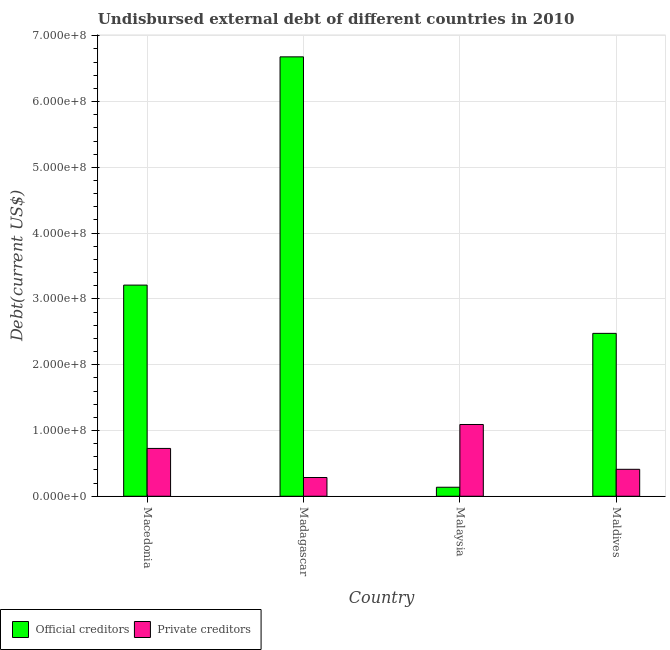Are the number of bars per tick equal to the number of legend labels?
Provide a short and direct response. Yes. Are the number of bars on each tick of the X-axis equal?
Ensure brevity in your answer.  Yes. What is the label of the 2nd group of bars from the left?
Your answer should be very brief. Madagascar. What is the undisbursed external debt of private creditors in Madagascar?
Offer a very short reply. 2.85e+07. Across all countries, what is the maximum undisbursed external debt of private creditors?
Ensure brevity in your answer.  1.09e+08. Across all countries, what is the minimum undisbursed external debt of official creditors?
Provide a short and direct response. 1.37e+07. In which country was the undisbursed external debt of private creditors maximum?
Give a very brief answer. Malaysia. In which country was the undisbursed external debt of official creditors minimum?
Your response must be concise. Malaysia. What is the total undisbursed external debt of official creditors in the graph?
Provide a short and direct response. 1.25e+09. What is the difference between the undisbursed external debt of official creditors in Malaysia and that in Maldives?
Your response must be concise. -2.34e+08. What is the difference between the undisbursed external debt of official creditors in Maldives and the undisbursed external debt of private creditors in Madagascar?
Provide a succinct answer. 2.19e+08. What is the average undisbursed external debt of private creditors per country?
Your response must be concise. 6.28e+07. What is the difference between the undisbursed external debt of private creditors and undisbursed external debt of official creditors in Macedonia?
Offer a very short reply. -2.48e+08. What is the ratio of the undisbursed external debt of official creditors in Madagascar to that in Malaysia?
Keep it short and to the point. 48.81. Is the undisbursed external debt of official creditors in Malaysia less than that in Maldives?
Provide a succinct answer. Yes. What is the difference between the highest and the second highest undisbursed external debt of official creditors?
Your response must be concise. 3.47e+08. What is the difference between the highest and the lowest undisbursed external debt of private creditors?
Give a very brief answer. 8.06e+07. In how many countries, is the undisbursed external debt of private creditors greater than the average undisbursed external debt of private creditors taken over all countries?
Make the answer very short. 2. Is the sum of the undisbursed external debt of official creditors in Madagascar and Maldives greater than the maximum undisbursed external debt of private creditors across all countries?
Make the answer very short. Yes. What does the 1st bar from the left in Malaysia represents?
Your response must be concise. Official creditors. What does the 2nd bar from the right in Maldives represents?
Give a very brief answer. Official creditors. How many bars are there?
Ensure brevity in your answer.  8. Are all the bars in the graph horizontal?
Ensure brevity in your answer.  No. How many countries are there in the graph?
Offer a terse response. 4. What is the difference between two consecutive major ticks on the Y-axis?
Offer a very short reply. 1.00e+08. Does the graph contain grids?
Make the answer very short. Yes. What is the title of the graph?
Your response must be concise. Undisbursed external debt of different countries in 2010. What is the label or title of the X-axis?
Your response must be concise. Country. What is the label or title of the Y-axis?
Provide a succinct answer. Debt(current US$). What is the Debt(current US$) of Official creditors in Macedonia?
Offer a very short reply. 3.21e+08. What is the Debt(current US$) of Private creditors in Macedonia?
Ensure brevity in your answer.  7.27e+07. What is the Debt(current US$) of Official creditors in Madagascar?
Offer a terse response. 6.68e+08. What is the Debt(current US$) of Private creditors in Madagascar?
Your answer should be compact. 2.85e+07. What is the Debt(current US$) of Official creditors in Malaysia?
Your answer should be very brief. 1.37e+07. What is the Debt(current US$) in Private creditors in Malaysia?
Your response must be concise. 1.09e+08. What is the Debt(current US$) of Official creditors in Maldives?
Your answer should be very brief. 2.48e+08. What is the Debt(current US$) in Private creditors in Maldives?
Your answer should be compact. 4.10e+07. Across all countries, what is the maximum Debt(current US$) in Official creditors?
Offer a very short reply. 6.68e+08. Across all countries, what is the maximum Debt(current US$) of Private creditors?
Give a very brief answer. 1.09e+08. Across all countries, what is the minimum Debt(current US$) in Official creditors?
Give a very brief answer. 1.37e+07. Across all countries, what is the minimum Debt(current US$) of Private creditors?
Offer a very short reply. 2.85e+07. What is the total Debt(current US$) in Official creditors in the graph?
Ensure brevity in your answer.  1.25e+09. What is the total Debt(current US$) of Private creditors in the graph?
Provide a short and direct response. 2.51e+08. What is the difference between the Debt(current US$) in Official creditors in Macedonia and that in Madagascar?
Provide a succinct answer. -3.47e+08. What is the difference between the Debt(current US$) of Private creditors in Macedonia and that in Madagascar?
Provide a short and direct response. 4.42e+07. What is the difference between the Debt(current US$) in Official creditors in Macedonia and that in Malaysia?
Keep it short and to the point. 3.07e+08. What is the difference between the Debt(current US$) in Private creditors in Macedonia and that in Malaysia?
Keep it short and to the point. -3.64e+07. What is the difference between the Debt(current US$) of Official creditors in Macedonia and that in Maldives?
Keep it short and to the point. 7.34e+07. What is the difference between the Debt(current US$) of Private creditors in Macedonia and that in Maldives?
Ensure brevity in your answer.  3.17e+07. What is the difference between the Debt(current US$) of Official creditors in Madagascar and that in Malaysia?
Ensure brevity in your answer.  6.54e+08. What is the difference between the Debt(current US$) of Private creditors in Madagascar and that in Malaysia?
Make the answer very short. -8.06e+07. What is the difference between the Debt(current US$) of Official creditors in Madagascar and that in Maldives?
Your response must be concise. 4.20e+08. What is the difference between the Debt(current US$) in Private creditors in Madagascar and that in Maldives?
Your answer should be compact. -1.25e+07. What is the difference between the Debt(current US$) in Official creditors in Malaysia and that in Maldives?
Your answer should be very brief. -2.34e+08. What is the difference between the Debt(current US$) in Private creditors in Malaysia and that in Maldives?
Your answer should be very brief. 6.81e+07. What is the difference between the Debt(current US$) of Official creditors in Macedonia and the Debt(current US$) of Private creditors in Madagascar?
Keep it short and to the point. 2.92e+08. What is the difference between the Debt(current US$) of Official creditors in Macedonia and the Debt(current US$) of Private creditors in Malaysia?
Offer a very short reply. 2.12e+08. What is the difference between the Debt(current US$) of Official creditors in Macedonia and the Debt(current US$) of Private creditors in Maldives?
Provide a short and direct response. 2.80e+08. What is the difference between the Debt(current US$) of Official creditors in Madagascar and the Debt(current US$) of Private creditors in Malaysia?
Your answer should be compact. 5.59e+08. What is the difference between the Debt(current US$) of Official creditors in Madagascar and the Debt(current US$) of Private creditors in Maldives?
Give a very brief answer. 6.27e+08. What is the difference between the Debt(current US$) in Official creditors in Malaysia and the Debt(current US$) in Private creditors in Maldives?
Offer a terse response. -2.73e+07. What is the average Debt(current US$) of Official creditors per country?
Keep it short and to the point. 3.13e+08. What is the average Debt(current US$) in Private creditors per country?
Give a very brief answer. 6.28e+07. What is the difference between the Debt(current US$) in Official creditors and Debt(current US$) in Private creditors in Macedonia?
Ensure brevity in your answer.  2.48e+08. What is the difference between the Debt(current US$) of Official creditors and Debt(current US$) of Private creditors in Madagascar?
Offer a terse response. 6.40e+08. What is the difference between the Debt(current US$) in Official creditors and Debt(current US$) in Private creditors in Malaysia?
Your answer should be very brief. -9.54e+07. What is the difference between the Debt(current US$) in Official creditors and Debt(current US$) in Private creditors in Maldives?
Ensure brevity in your answer.  2.07e+08. What is the ratio of the Debt(current US$) in Official creditors in Macedonia to that in Madagascar?
Provide a succinct answer. 0.48. What is the ratio of the Debt(current US$) of Private creditors in Macedonia to that in Madagascar?
Your answer should be compact. 2.55. What is the ratio of the Debt(current US$) in Official creditors in Macedonia to that in Malaysia?
Offer a very short reply. 23.46. What is the ratio of the Debt(current US$) of Private creditors in Macedonia to that in Malaysia?
Keep it short and to the point. 0.67. What is the ratio of the Debt(current US$) in Official creditors in Macedonia to that in Maldives?
Keep it short and to the point. 1.3. What is the ratio of the Debt(current US$) in Private creditors in Macedonia to that in Maldives?
Your answer should be compact. 1.77. What is the ratio of the Debt(current US$) of Official creditors in Madagascar to that in Malaysia?
Make the answer very short. 48.81. What is the ratio of the Debt(current US$) of Private creditors in Madagascar to that in Malaysia?
Your answer should be compact. 0.26. What is the ratio of the Debt(current US$) in Official creditors in Madagascar to that in Maldives?
Provide a succinct answer. 2.7. What is the ratio of the Debt(current US$) in Private creditors in Madagascar to that in Maldives?
Make the answer very short. 0.7. What is the ratio of the Debt(current US$) of Official creditors in Malaysia to that in Maldives?
Keep it short and to the point. 0.06. What is the ratio of the Debt(current US$) of Private creditors in Malaysia to that in Maldives?
Offer a terse response. 2.66. What is the difference between the highest and the second highest Debt(current US$) in Official creditors?
Your response must be concise. 3.47e+08. What is the difference between the highest and the second highest Debt(current US$) of Private creditors?
Your response must be concise. 3.64e+07. What is the difference between the highest and the lowest Debt(current US$) of Official creditors?
Keep it short and to the point. 6.54e+08. What is the difference between the highest and the lowest Debt(current US$) in Private creditors?
Ensure brevity in your answer.  8.06e+07. 